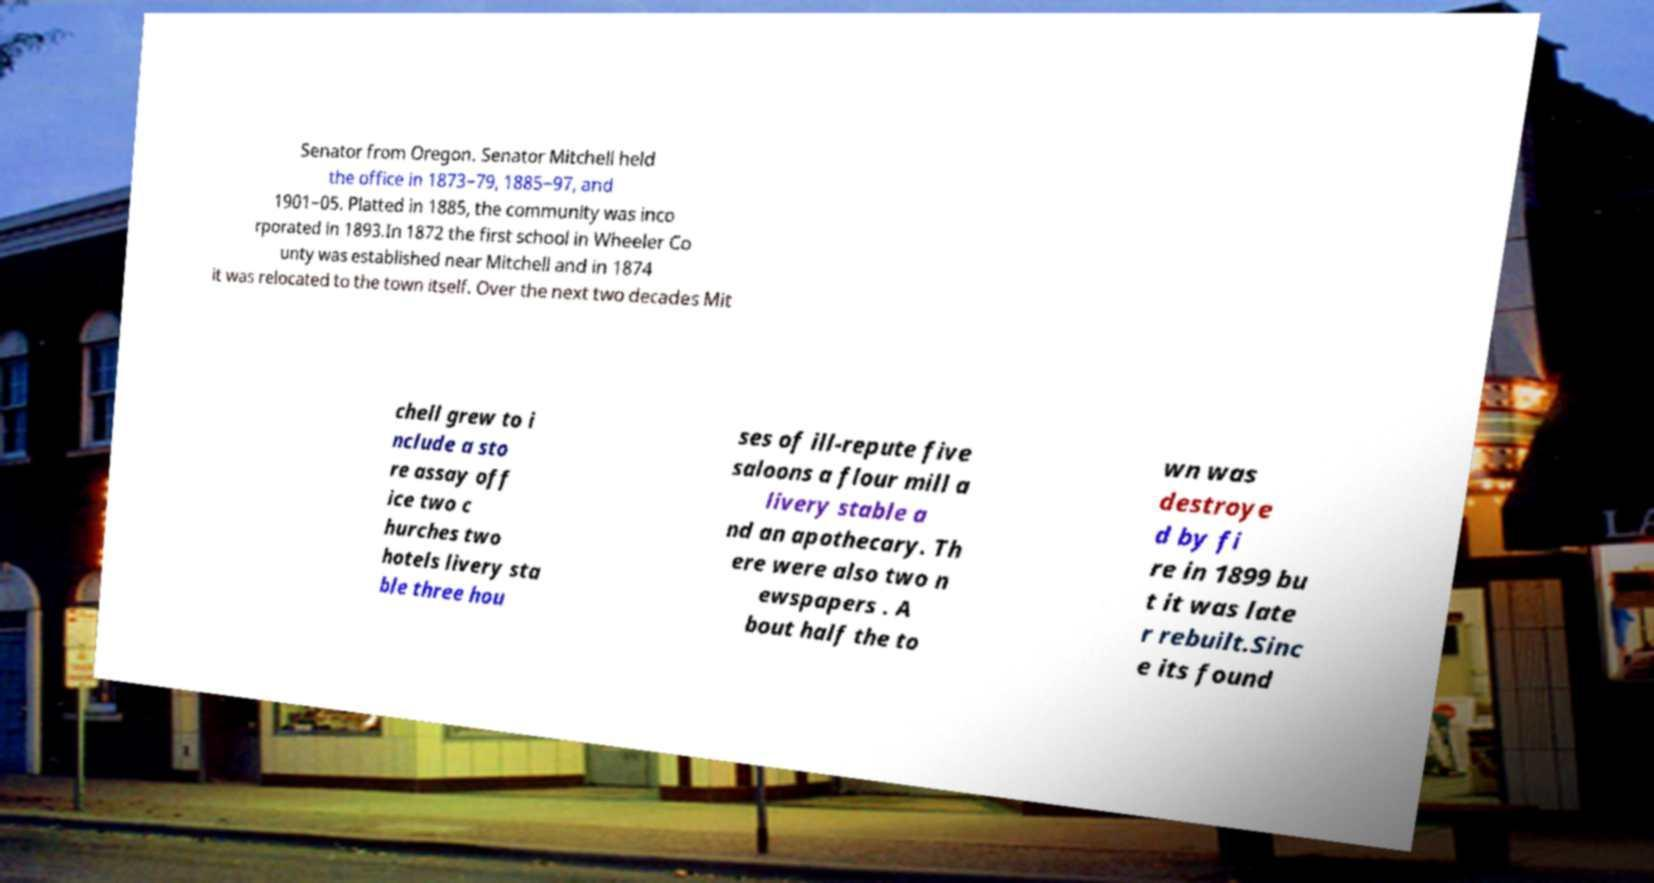Please read and relay the text visible in this image. What does it say? Senator from Oregon. Senator Mitchell held the office in 1873−79, 1885−97, and 1901−05. Platted in 1885, the community was inco rporated in 1893.In 1872 the first school in Wheeler Co unty was established near Mitchell and in 1874 it was relocated to the town itself. Over the next two decades Mit chell grew to i nclude a sto re assay off ice two c hurches two hotels livery sta ble three hou ses of ill-repute five saloons a flour mill a livery stable a nd an apothecary. Th ere were also two n ewspapers . A bout half the to wn was destroye d by fi re in 1899 bu t it was late r rebuilt.Sinc e its found 